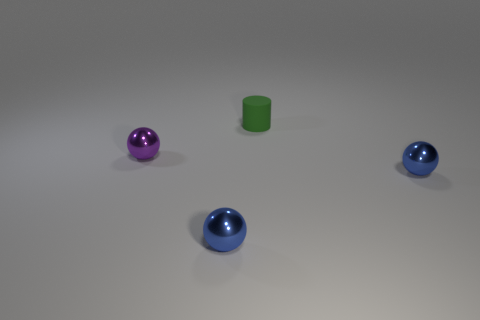Add 3 tiny cyan matte cubes. How many objects exist? 7 Subtract all blue spheres. How many spheres are left? 1 Subtract all gray cylinders. How many blue balls are left? 2 Subtract all purple spheres. How many spheres are left? 2 Subtract all spheres. How many objects are left? 1 Add 4 small metallic things. How many small metallic things are left? 7 Add 3 tiny purple things. How many tiny purple things exist? 4 Subtract 1 purple spheres. How many objects are left? 3 Subtract all gray balls. Subtract all yellow blocks. How many balls are left? 3 Subtract all small green rubber cylinders. Subtract all small green rubber things. How many objects are left? 2 